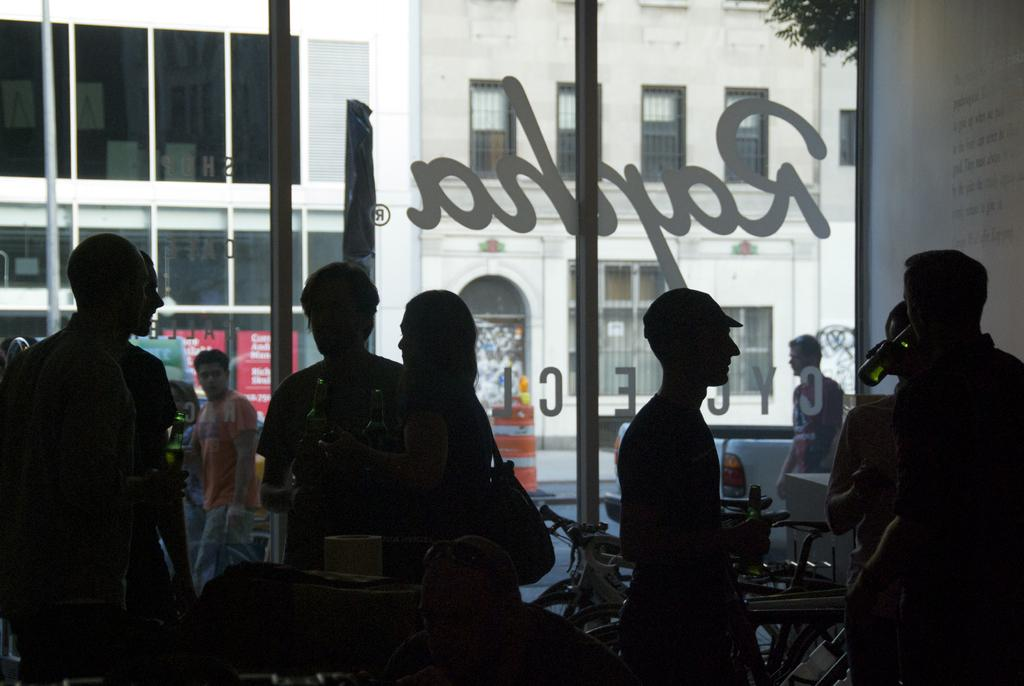How many people are in the image? There is a group of people in the image. What is located in the background of the image? There is a glass door and a window in the background of the image. What is happening outside the glass door? A man is walking outside the glass door. What can be seen outside the glass door? There is a building and a plant visible outside the glass door. What advice does the dad give to the achiever at the table in the image? There is no dad or achiever present in the image, nor is there a table. 